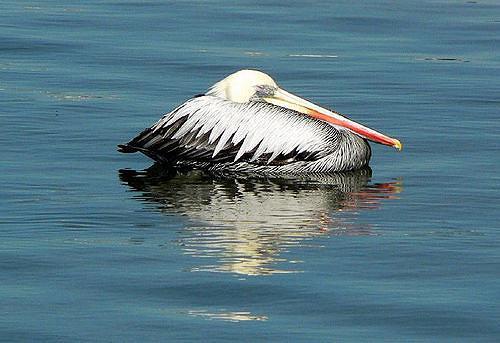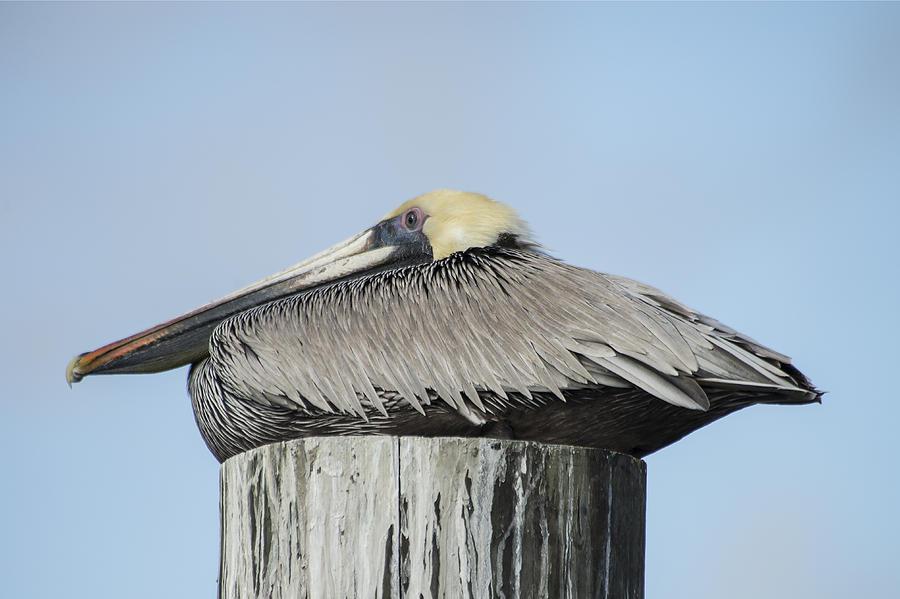The first image is the image on the left, the second image is the image on the right. Analyze the images presented: Is the assertion "Each image shows a pelican posed with its head and body flattened, and in one image a pelican is sitting atop a flat post." valid? Answer yes or no. Yes. The first image is the image on the left, the second image is the image on the right. Examine the images to the left and right. Is the description "One bird is on a pole pointed to the right." accurate? Answer yes or no. No. 